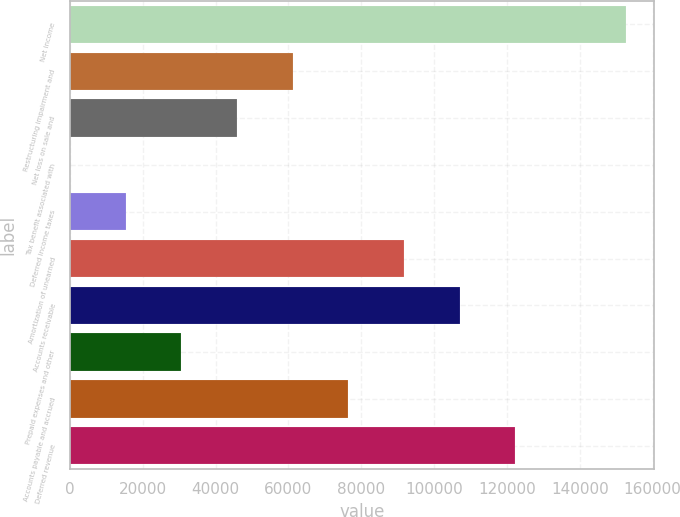Convert chart. <chart><loc_0><loc_0><loc_500><loc_500><bar_chart><fcel>Net income<fcel>Restructuring impairment and<fcel>Net loss on sale and<fcel>Tax benefit associated with<fcel>Deferred income taxes<fcel>Amortization of unearned<fcel>Accounts receivable<fcel>Prepaid expenses and other<fcel>Accounts payable and accrued<fcel>Deferred revenue<nl><fcel>152820<fcel>61151.4<fcel>45873.3<fcel>39<fcel>15317.1<fcel>91707.6<fcel>106986<fcel>30595.2<fcel>76429.5<fcel>122264<nl></chart> 